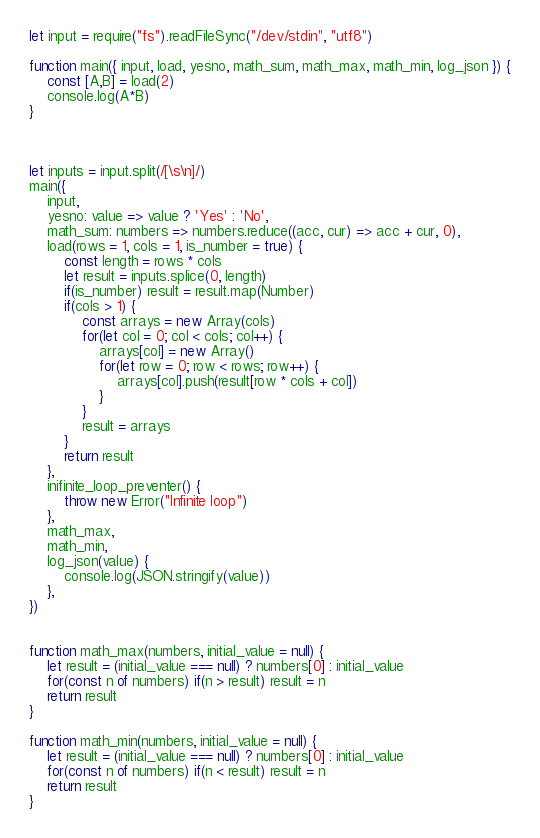<code> <loc_0><loc_0><loc_500><loc_500><_JavaScript_>
let input = require("fs").readFileSync("/dev/stdin", "utf8")

function main({ input, load, yesno, math_sum, math_max, math_min, log_json }) {
    const [A,B] = load(2)
    console.log(A*B)
}



let inputs = input.split(/[\s\n]/)
main({
    input,
    yesno: value => value ? 'Yes' : 'No',
    math_sum: numbers => numbers.reduce((acc, cur) => acc + cur, 0),
    load(rows = 1, cols = 1, is_number = true) {
        const length = rows * cols
        let result = inputs.splice(0, length)
        if(is_number) result = result.map(Number)
        if(cols > 1) {
            const arrays = new Array(cols)
            for(let col = 0; col < cols; col++) {
                arrays[col] = new Array()
                for(let row = 0; row < rows; row++) {
                    arrays[col].push(result[row * cols + col])
                }
            }
            result = arrays
        }
        return result
    },
    inifinite_loop_preventer() {
        throw new Error("Infinite loop")
    },
    math_max,
    math_min,
    log_json(value) {
        console.log(JSON.stringify(value))
    },
})


function math_max(numbers, initial_value = null) {
    let result = (initial_value === null) ? numbers[0] : initial_value
    for(const n of numbers) if(n > result) result = n
    return result
}

function math_min(numbers, initial_value = null) {
    let result = (initial_value === null) ? numbers[0] : initial_value
    for(const n of numbers) if(n < result) result = n
    return result
}
</code> 